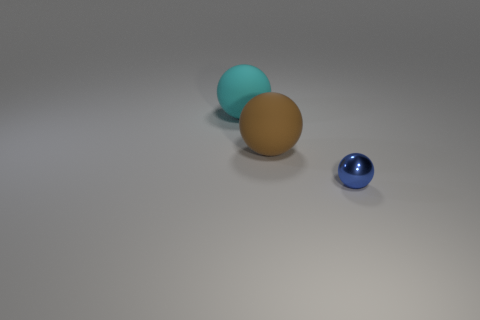Is the large ball in front of the large cyan rubber object made of the same material as the large cyan ball?
Offer a terse response. Yes. What is the size of the ball that is both behind the blue sphere and to the right of the cyan matte object?
Provide a short and direct response. Large. What color is the shiny thing?
Make the answer very short. Blue. How many small cyan rubber things are there?
Provide a short and direct response. 0. There is a object that is in front of the large matte thing that is in front of the sphere behind the brown matte thing; what color is it?
Make the answer very short. Blue. What color is the rubber sphere in front of the cyan object?
Provide a short and direct response. Brown. What color is the sphere that is the same size as the cyan matte thing?
Ensure brevity in your answer.  Brown. Do the metal thing and the brown rubber ball have the same size?
Your answer should be compact. No. There is a large brown object; what number of big things are behind it?
Make the answer very short. 1. What number of objects are balls that are on the left side of the brown ball or large brown objects?
Your answer should be very brief. 2. 